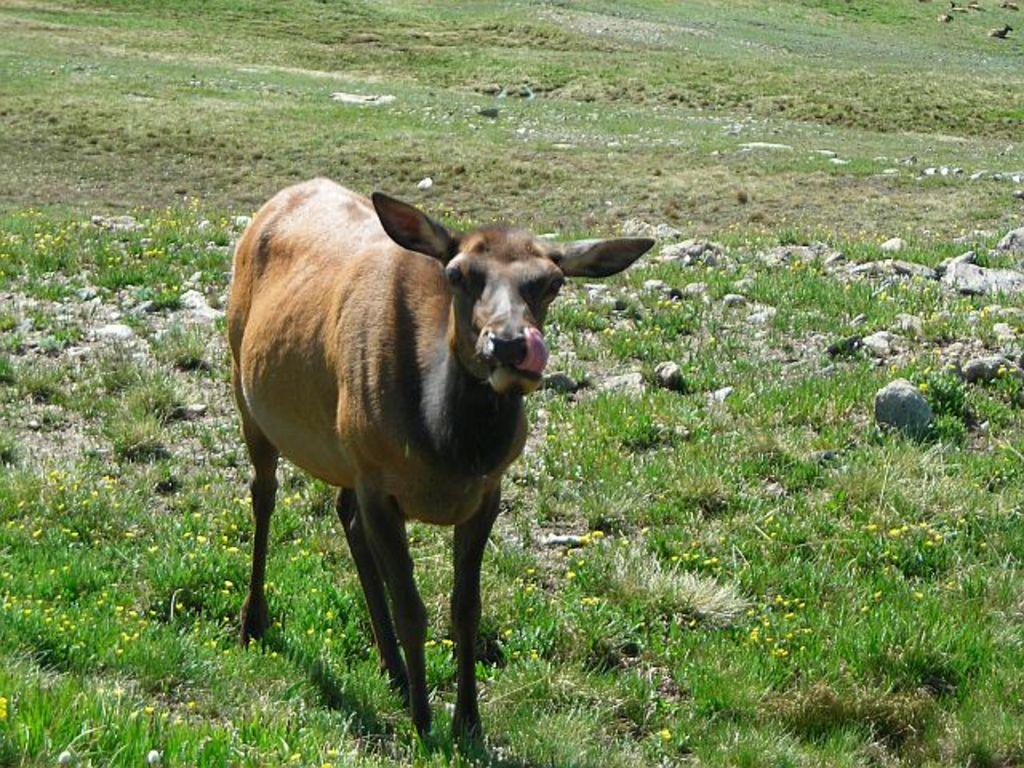Can you describe this image briefly? In this image, in the foreground there is an animal and this animal is surrounded by grass and small rocks. 